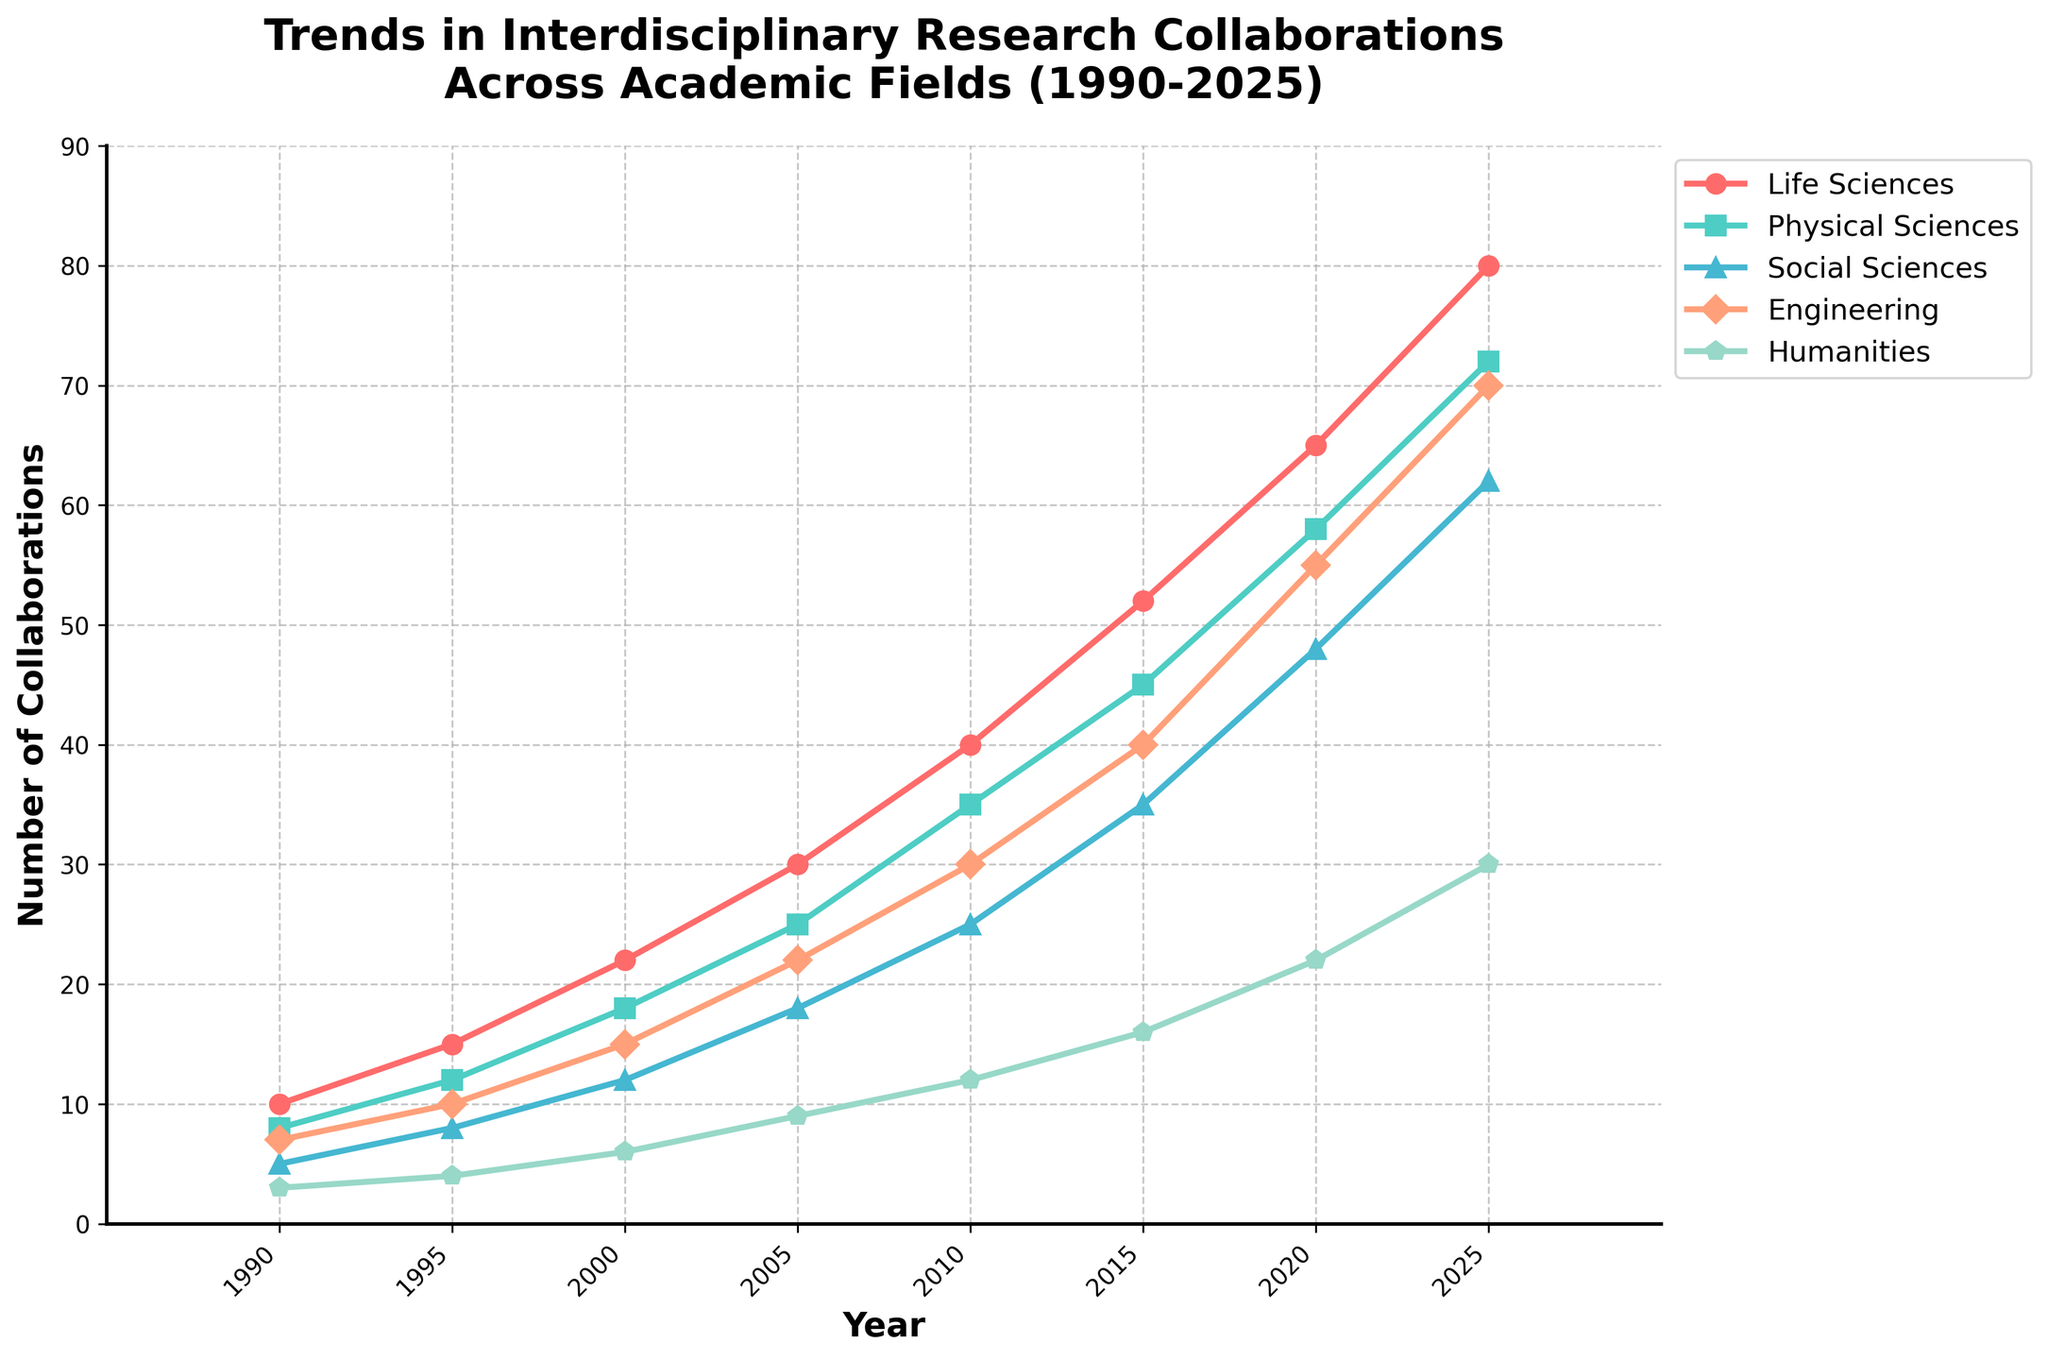What academic field experienced the most significant increase in interdisciplinary collaborations from 1990 to 2025? To find the academic field with the most significant increase, we need to subtract the number of collaborations in 1990 from the number in 2025 for each field and compare the differences. For Life Sciences: 80 - 10 = 70. For Physical Sciences: 72 - 8 = 64. For Social Sciences: 62 - 5 = 57. For Engineering: 70 - 7 = 63. For Humanities: 30 - 3 = 27. The Life Sciences had the most significant increase.
Answer: Life Sciences Between which years did the Social Sciences experience the most rapid increase in collaborations? To determine the period of the most rapid increase, calculate the differences between consecutive years for Social Sciences. The differences are from 1990 to 1995: 8 - 5 = 3; 1995 to 2000: 12 - 8 = 4; 2000 to 2005: 18 - 12 = 6; 2005 to 2010: 25 - 18 = 7; 2010 to 2015: 35 - 25 = 10; 2015 to 2020: 48 - 35 = 13; 2020 to 2025: 62 - 48 = 14. The most rapid increase was from 2020 to 2025.
Answer: 2020 to 2025 Which academic fields had a number of collaborations equal or exceeding 50 by 2015? Observe the number of collaborations in the year 2015. Life Sciences: 52, Physical Sciences: 45, Social Sciences: 35, Engineering: 40, Humanities: 16. Only Life Sciences had collaborations equal or exceeding 50 by 2015.
Answer: Life Sciences How do the trends in collaborations for Engineering and Physical Sciences compare between 2005 and 2025? Compare the number of collaborations for these two fields in the years 2005 and 2025. For Engineering: 22 to 70, which is an increase of 48. For Physical Sciences: 25 to 72, which is an increase of 47. The trends for both fields show a similar significant increase, but Engineering slightly surpasses Physical Sciences over the period.
Answer: Engineering (slightly higher increase) What's the average number of collaborations for the Humanities in the years shown? Calculate the average for the Humanities across the years 1990, 1995, 2000, 2005, 2010, 2015, 2020, and 2025. These values are 3, 4, 6, 9, 12, 16, 22, and 30. Sum: 3 + 4 + 6 + 9 + 12 + 16 + 22 + 30 = 102. There are 8 data points, so average = 102/8 = 12.75.
Answer: 12.75 Which academic field had the least number of collaborations in 1995, and how many were there? Look at the year 1995 and identify the field with the smallest value. Life Sciences: 15, Physical Sciences: 12, Social Sciences: 8, Engineering: 10, Humanities: 4. The Humanities had the least with 4.
Answer: Humanities, 4 What is the total number of collaborations for Social Sciences over all years shown? Sum the number of collaborations for Social Sciences across all years provided: 5 + 8 + 12 + 18 + 25 + 35 + 48 + 62 = 213.
Answer: 213 If the trend continues, what is the expected number of Engineering collaborations in 2030 (assuming a linear progression from 2015 to 2025)? Calculate the annual increase from 2015 to 2025, then project it to 2030. From 2015 to 2025: 70 - 40 = 30 increase over 10 years, hence 30/10 = 3 per year. By 2030, 5 more years would add 3 * 5 = 15 to the 2025 value, so 70 + 15 = 85.
Answer: 85 